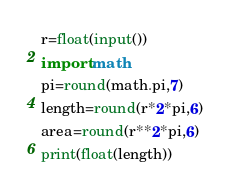Convert code to text. <code><loc_0><loc_0><loc_500><loc_500><_Python_>r=float(input())
import math
pi=round(math.pi,7)
length=round(r*2*pi,6)
area=round(r**2*pi,6)
print(float(length))
</code> 